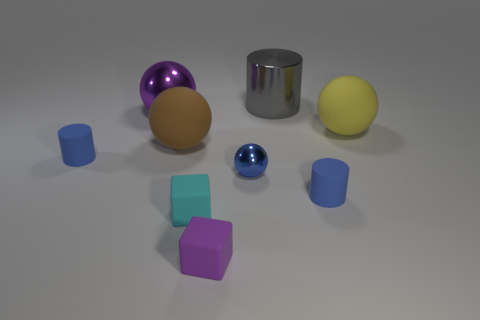Subtract all purple spheres. How many spheres are left? 3 Subtract all cylinders. How many objects are left? 6 Add 1 green shiny cylinders. How many objects exist? 10 Subtract all big green metal cubes. Subtract all brown rubber objects. How many objects are left? 8 Add 6 metallic cylinders. How many metallic cylinders are left? 7 Add 5 purple objects. How many purple objects exist? 7 Subtract all cyan cubes. How many cubes are left? 1 Subtract 0 brown cylinders. How many objects are left? 9 Subtract 4 balls. How many balls are left? 0 Subtract all brown balls. Subtract all red cubes. How many balls are left? 3 